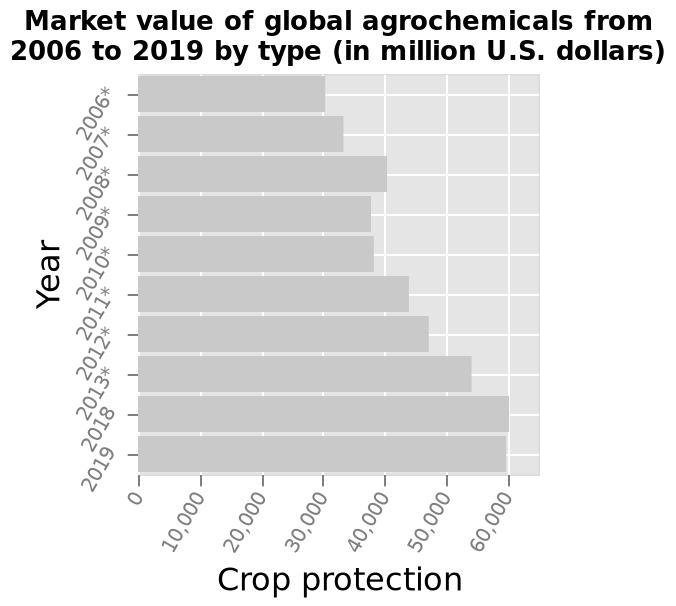<image>
What does the y-axis represent in the bar chart?  The y-axis in the bar chart represents the years from 2006 to 2019. Which year saw a decrease in crop protection?  The year 2008 witnessed a decrease in crop protection. What pattern can be observed in the trend of crop protection over the years? The trend of crop protection shows a consistent increase, with a sharp rise from 2006 to 2019, except for a decline in 2008. What is the measurement unit used for the market value of global agrochemicals?  The measurement unit used for the market value of global agrochemicals is million U.S. dollars. 